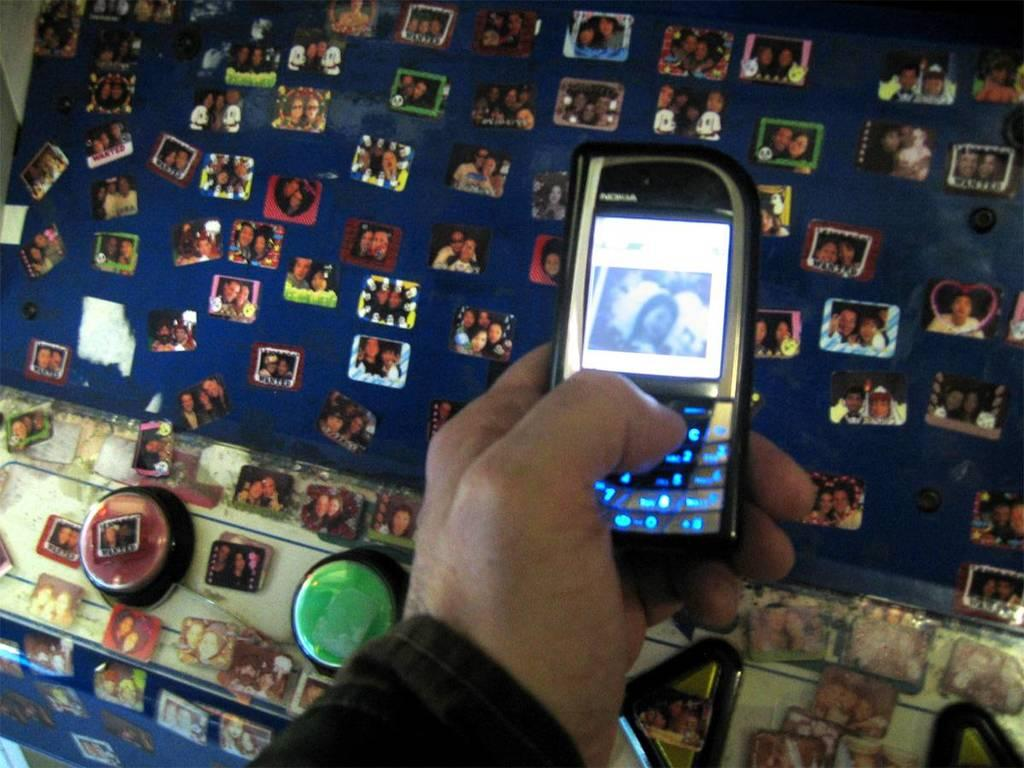<image>
Offer a succinct explanation of the picture presented. A nokia cellphone being held with a picture of  a girl displayed. 